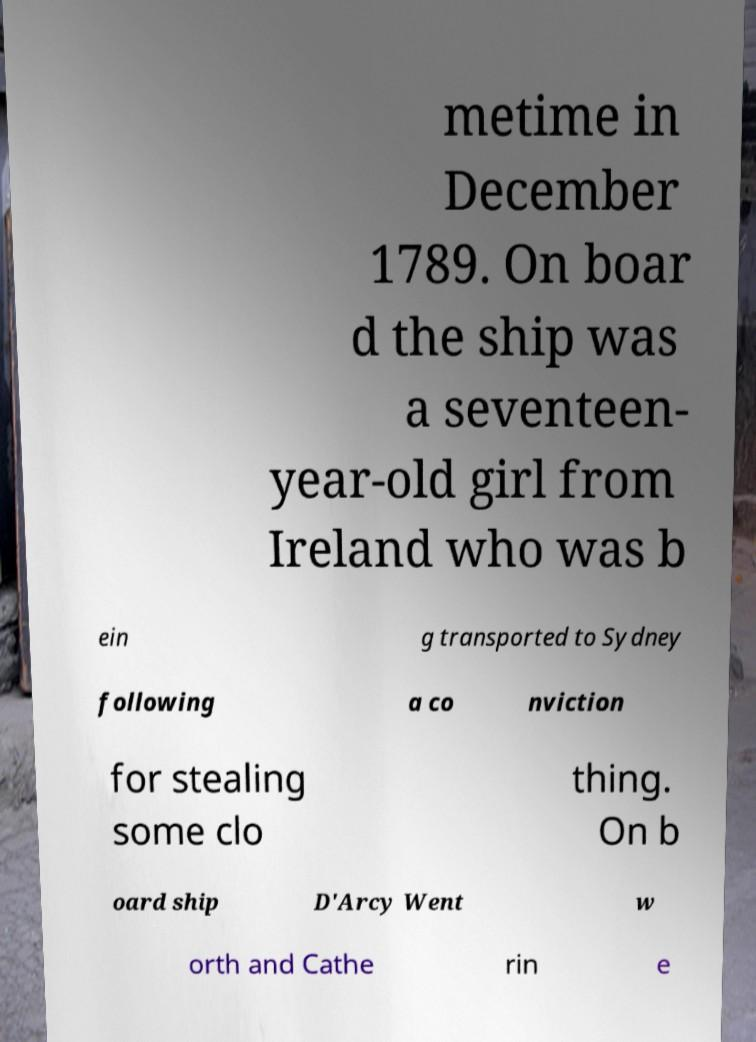Can you accurately transcribe the text from the provided image for me? metime in December 1789. On boar d the ship was a seventeen- year-old girl from Ireland who was b ein g transported to Sydney following a co nviction for stealing some clo thing. On b oard ship D'Arcy Went w orth and Cathe rin e 